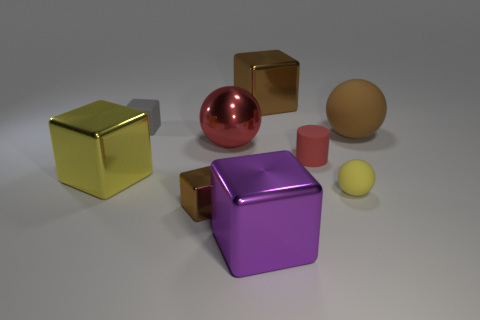Subtract all gray cubes. How many cubes are left? 4 Subtract all tiny metal cubes. How many cubes are left? 4 Subtract all blue blocks. Subtract all brown spheres. How many blocks are left? 5 Add 1 small shiny blocks. How many objects exist? 10 Subtract all cylinders. How many objects are left? 8 Subtract all large blue rubber cylinders. Subtract all small gray rubber cubes. How many objects are left? 8 Add 2 tiny yellow matte balls. How many tiny yellow matte balls are left? 3 Add 2 tiny cylinders. How many tiny cylinders exist? 3 Subtract 0 green balls. How many objects are left? 9 